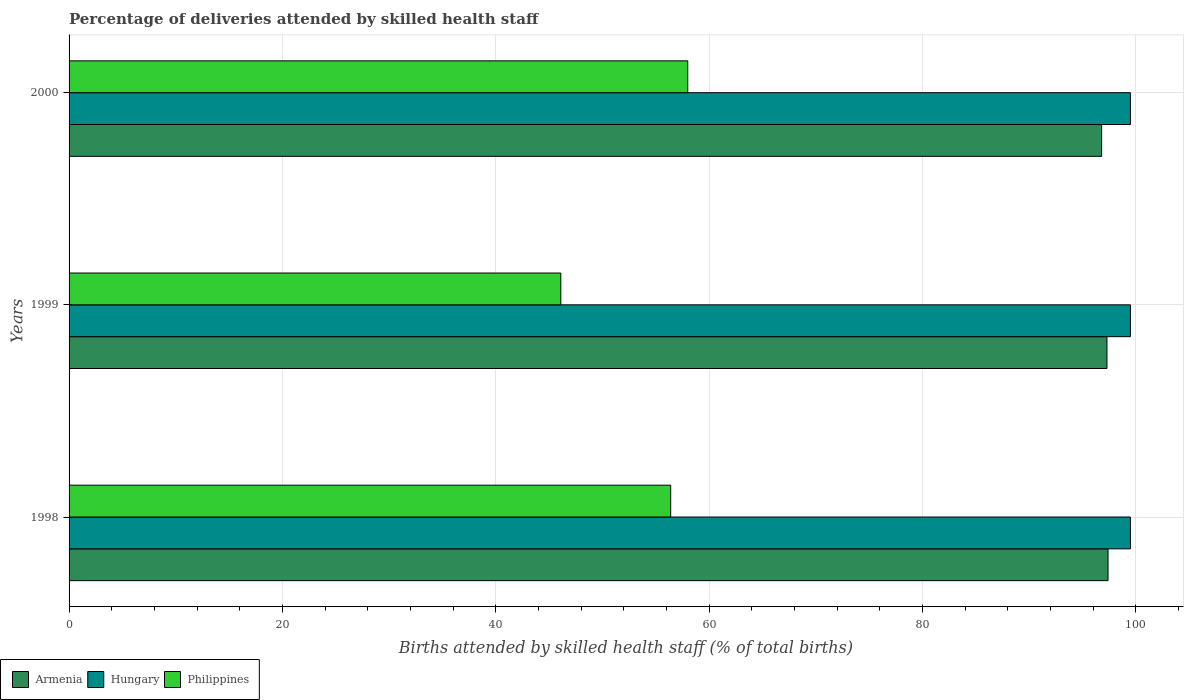How many different coloured bars are there?
Make the answer very short. 3. How many groups of bars are there?
Provide a short and direct response. 3. Are the number of bars per tick equal to the number of legend labels?
Make the answer very short. Yes. How many bars are there on the 3rd tick from the bottom?
Give a very brief answer. 3. What is the label of the 3rd group of bars from the top?
Offer a terse response. 1998. In how many cases, is the number of bars for a given year not equal to the number of legend labels?
Provide a succinct answer. 0. What is the percentage of births attended by skilled health staff in Armenia in 2000?
Your response must be concise. 96.8. Across all years, what is the maximum percentage of births attended by skilled health staff in Armenia?
Provide a short and direct response. 97.4. Across all years, what is the minimum percentage of births attended by skilled health staff in Hungary?
Provide a short and direct response. 99.5. In which year was the percentage of births attended by skilled health staff in Armenia minimum?
Make the answer very short. 2000. What is the total percentage of births attended by skilled health staff in Philippines in the graph?
Offer a very short reply. 160.5. What is the difference between the percentage of births attended by skilled health staff in Hungary in 1998 and that in 2000?
Keep it short and to the point. 0. What is the difference between the percentage of births attended by skilled health staff in Philippines in 2000 and the percentage of births attended by skilled health staff in Hungary in 1999?
Ensure brevity in your answer.  -41.5. What is the average percentage of births attended by skilled health staff in Philippines per year?
Provide a succinct answer. 53.5. In the year 2000, what is the difference between the percentage of births attended by skilled health staff in Hungary and percentage of births attended by skilled health staff in Philippines?
Your answer should be compact. 41.5. In how many years, is the percentage of births attended by skilled health staff in Hungary greater than 92 %?
Your response must be concise. 3. What is the ratio of the percentage of births attended by skilled health staff in Hungary in 1998 to that in 1999?
Ensure brevity in your answer.  1. What is the difference between the highest and the second highest percentage of births attended by skilled health staff in Armenia?
Your response must be concise. 0.1. In how many years, is the percentage of births attended by skilled health staff in Armenia greater than the average percentage of births attended by skilled health staff in Armenia taken over all years?
Offer a terse response. 2. Is the sum of the percentage of births attended by skilled health staff in Philippines in 1998 and 1999 greater than the maximum percentage of births attended by skilled health staff in Armenia across all years?
Provide a short and direct response. Yes. What does the 2nd bar from the top in 1998 represents?
Provide a short and direct response. Hungary. What does the 1st bar from the bottom in 1998 represents?
Offer a very short reply. Armenia. How many years are there in the graph?
Keep it short and to the point. 3. Are the values on the major ticks of X-axis written in scientific E-notation?
Give a very brief answer. No. Where does the legend appear in the graph?
Your response must be concise. Bottom left. How many legend labels are there?
Your response must be concise. 3. How are the legend labels stacked?
Make the answer very short. Horizontal. What is the title of the graph?
Provide a succinct answer. Percentage of deliveries attended by skilled health staff. What is the label or title of the X-axis?
Keep it short and to the point. Births attended by skilled health staff (% of total births). What is the label or title of the Y-axis?
Offer a very short reply. Years. What is the Births attended by skilled health staff (% of total births) in Armenia in 1998?
Your response must be concise. 97.4. What is the Births attended by skilled health staff (% of total births) of Hungary in 1998?
Your response must be concise. 99.5. What is the Births attended by skilled health staff (% of total births) in Philippines in 1998?
Your answer should be very brief. 56.4. What is the Births attended by skilled health staff (% of total births) in Armenia in 1999?
Your response must be concise. 97.3. What is the Births attended by skilled health staff (% of total births) of Hungary in 1999?
Your answer should be very brief. 99.5. What is the Births attended by skilled health staff (% of total births) of Philippines in 1999?
Your response must be concise. 46.1. What is the Births attended by skilled health staff (% of total births) of Armenia in 2000?
Provide a short and direct response. 96.8. What is the Births attended by skilled health staff (% of total births) in Hungary in 2000?
Offer a very short reply. 99.5. Across all years, what is the maximum Births attended by skilled health staff (% of total births) of Armenia?
Make the answer very short. 97.4. Across all years, what is the maximum Births attended by skilled health staff (% of total births) in Hungary?
Provide a succinct answer. 99.5. Across all years, what is the maximum Births attended by skilled health staff (% of total births) of Philippines?
Provide a succinct answer. 58. Across all years, what is the minimum Births attended by skilled health staff (% of total births) of Armenia?
Offer a very short reply. 96.8. Across all years, what is the minimum Births attended by skilled health staff (% of total births) of Hungary?
Your answer should be very brief. 99.5. Across all years, what is the minimum Births attended by skilled health staff (% of total births) in Philippines?
Your answer should be very brief. 46.1. What is the total Births attended by skilled health staff (% of total births) of Armenia in the graph?
Your answer should be compact. 291.5. What is the total Births attended by skilled health staff (% of total births) of Hungary in the graph?
Give a very brief answer. 298.5. What is the total Births attended by skilled health staff (% of total births) in Philippines in the graph?
Your answer should be very brief. 160.5. What is the difference between the Births attended by skilled health staff (% of total births) in Hungary in 1998 and that in 1999?
Your answer should be very brief. 0. What is the difference between the Births attended by skilled health staff (% of total births) of Hungary in 1998 and that in 2000?
Make the answer very short. 0. What is the difference between the Births attended by skilled health staff (% of total births) in Philippines in 1998 and that in 2000?
Offer a terse response. -1.6. What is the difference between the Births attended by skilled health staff (% of total births) of Philippines in 1999 and that in 2000?
Offer a terse response. -11.9. What is the difference between the Births attended by skilled health staff (% of total births) in Armenia in 1998 and the Births attended by skilled health staff (% of total births) in Hungary in 1999?
Provide a short and direct response. -2.1. What is the difference between the Births attended by skilled health staff (% of total births) of Armenia in 1998 and the Births attended by skilled health staff (% of total births) of Philippines in 1999?
Offer a terse response. 51.3. What is the difference between the Births attended by skilled health staff (% of total births) of Hungary in 1998 and the Births attended by skilled health staff (% of total births) of Philippines in 1999?
Your response must be concise. 53.4. What is the difference between the Births attended by skilled health staff (% of total births) in Armenia in 1998 and the Births attended by skilled health staff (% of total births) in Philippines in 2000?
Provide a short and direct response. 39.4. What is the difference between the Births attended by skilled health staff (% of total births) in Hungary in 1998 and the Births attended by skilled health staff (% of total births) in Philippines in 2000?
Provide a short and direct response. 41.5. What is the difference between the Births attended by skilled health staff (% of total births) in Armenia in 1999 and the Births attended by skilled health staff (% of total births) in Philippines in 2000?
Keep it short and to the point. 39.3. What is the difference between the Births attended by skilled health staff (% of total births) in Hungary in 1999 and the Births attended by skilled health staff (% of total births) in Philippines in 2000?
Ensure brevity in your answer.  41.5. What is the average Births attended by skilled health staff (% of total births) of Armenia per year?
Keep it short and to the point. 97.17. What is the average Births attended by skilled health staff (% of total births) of Hungary per year?
Ensure brevity in your answer.  99.5. What is the average Births attended by skilled health staff (% of total births) of Philippines per year?
Give a very brief answer. 53.5. In the year 1998, what is the difference between the Births attended by skilled health staff (% of total births) of Armenia and Births attended by skilled health staff (% of total births) of Hungary?
Your answer should be very brief. -2.1. In the year 1998, what is the difference between the Births attended by skilled health staff (% of total births) of Armenia and Births attended by skilled health staff (% of total births) of Philippines?
Provide a short and direct response. 41. In the year 1998, what is the difference between the Births attended by skilled health staff (% of total births) of Hungary and Births attended by skilled health staff (% of total births) of Philippines?
Offer a terse response. 43.1. In the year 1999, what is the difference between the Births attended by skilled health staff (% of total births) in Armenia and Births attended by skilled health staff (% of total births) in Hungary?
Offer a terse response. -2.2. In the year 1999, what is the difference between the Births attended by skilled health staff (% of total births) of Armenia and Births attended by skilled health staff (% of total births) of Philippines?
Your response must be concise. 51.2. In the year 1999, what is the difference between the Births attended by skilled health staff (% of total births) in Hungary and Births attended by skilled health staff (% of total births) in Philippines?
Offer a terse response. 53.4. In the year 2000, what is the difference between the Births attended by skilled health staff (% of total births) of Armenia and Births attended by skilled health staff (% of total births) of Hungary?
Provide a short and direct response. -2.7. In the year 2000, what is the difference between the Births attended by skilled health staff (% of total births) of Armenia and Births attended by skilled health staff (% of total births) of Philippines?
Your answer should be compact. 38.8. In the year 2000, what is the difference between the Births attended by skilled health staff (% of total births) of Hungary and Births attended by skilled health staff (% of total births) of Philippines?
Offer a terse response. 41.5. What is the ratio of the Births attended by skilled health staff (% of total births) of Armenia in 1998 to that in 1999?
Provide a succinct answer. 1. What is the ratio of the Births attended by skilled health staff (% of total births) in Hungary in 1998 to that in 1999?
Provide a succinct answer. 1. What is the ratio of the Births attended by skilled health staff (% of total births) in Philippines in 1998 to that in 1999?
Offer a very short reply. 1.22. What is the ratio of the Births attended by skilled health staff (% of total births) in Armenia in 1998 to that in 2000?
Offer a very short reply. 1.01. What is the ratio of the Births attended by skilled health staff (% of total births) of Philippines in 1998 to that in 2000?
Your answer should be compact. 0.97. What is the ratio of the Births attended by skilled health staff (% of total births) in Philippines in 1999 to that in 2000?
Your response must be concise. 0.79. What is the difference between the highest and the second highest Births attended by skilled health staff (% of total births) of Philippines?
Ensure brevity in your answer.  1.6. What is the difference between the highest and the lowest Births attended by skilled health staff (% of total births) of Armenia?
Your response must be concise. 0.6. What is the difference between the highest and the lowest Births attended by skilled health staff (% of total births) of Hungary?
Your response must be concise. 0. What is the difference between the highest and the lowest Births attended by skilled health staff (% of total births) in Philippines?
Offer a very short reply. 11.9. 